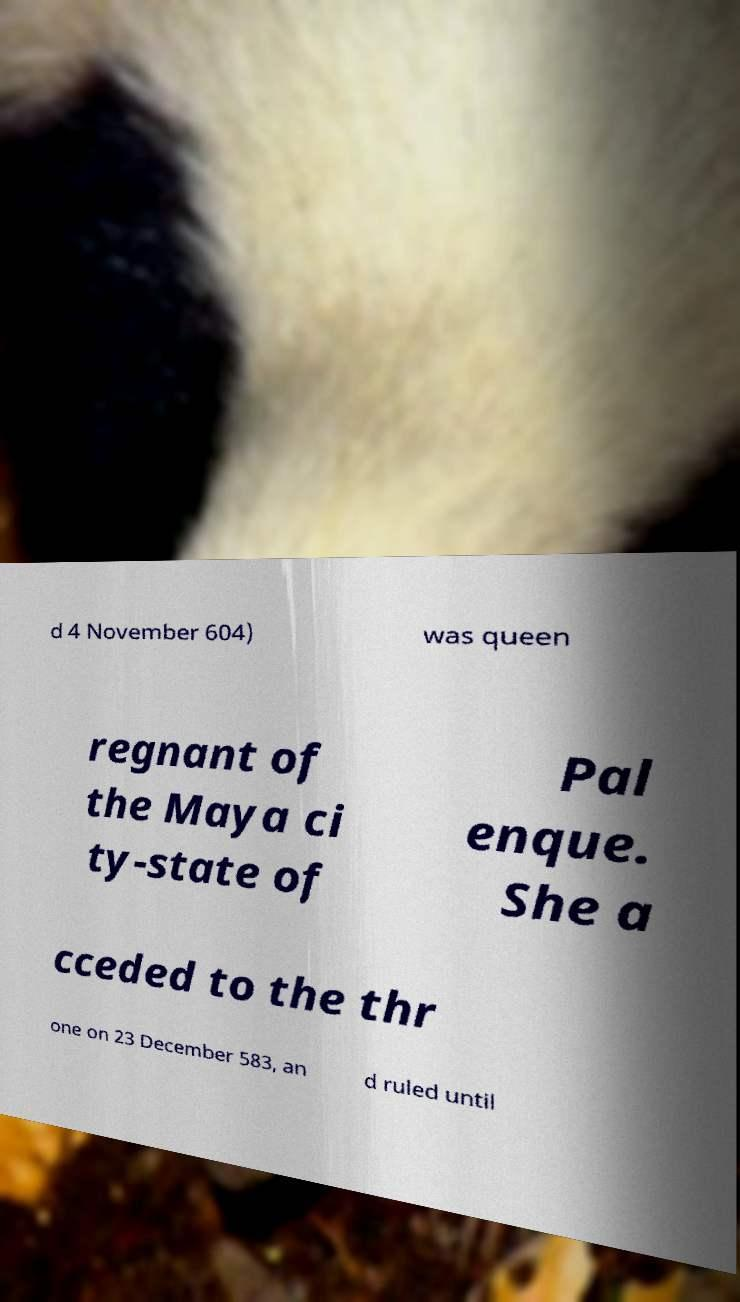Can you read and provide the text displayed in the image?This photo seems to have some interesting text. Can you extract and type it out for me? d 4 November 604) was queen regnant of the Maya ci ty-state of Pal enque. She a cceded to the thr one on 23 December 583, an d ruled until 